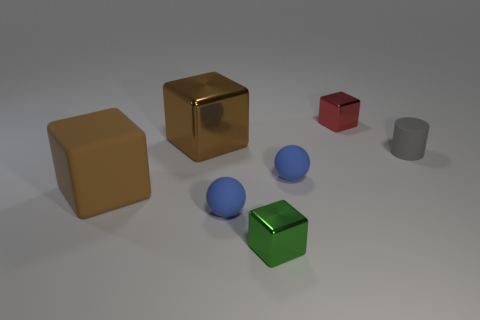Subtract all purple spheres. Subtract all cyan cubes. How many spheres are left? 2 Add 2 large metal objects. How many objects exist? 9 Subtract all cubes. How many objects are left? 3 Subtract 1 gray cylinders. How many objects are left? 6 Subtract all blue matte cubes. Subtract all small red metallic objects. How many objects are left? 6 Add 4 small blue matte things. How many small blue matte things are left? 6 Add 7 large brown things. How many large brown things exist? 9 